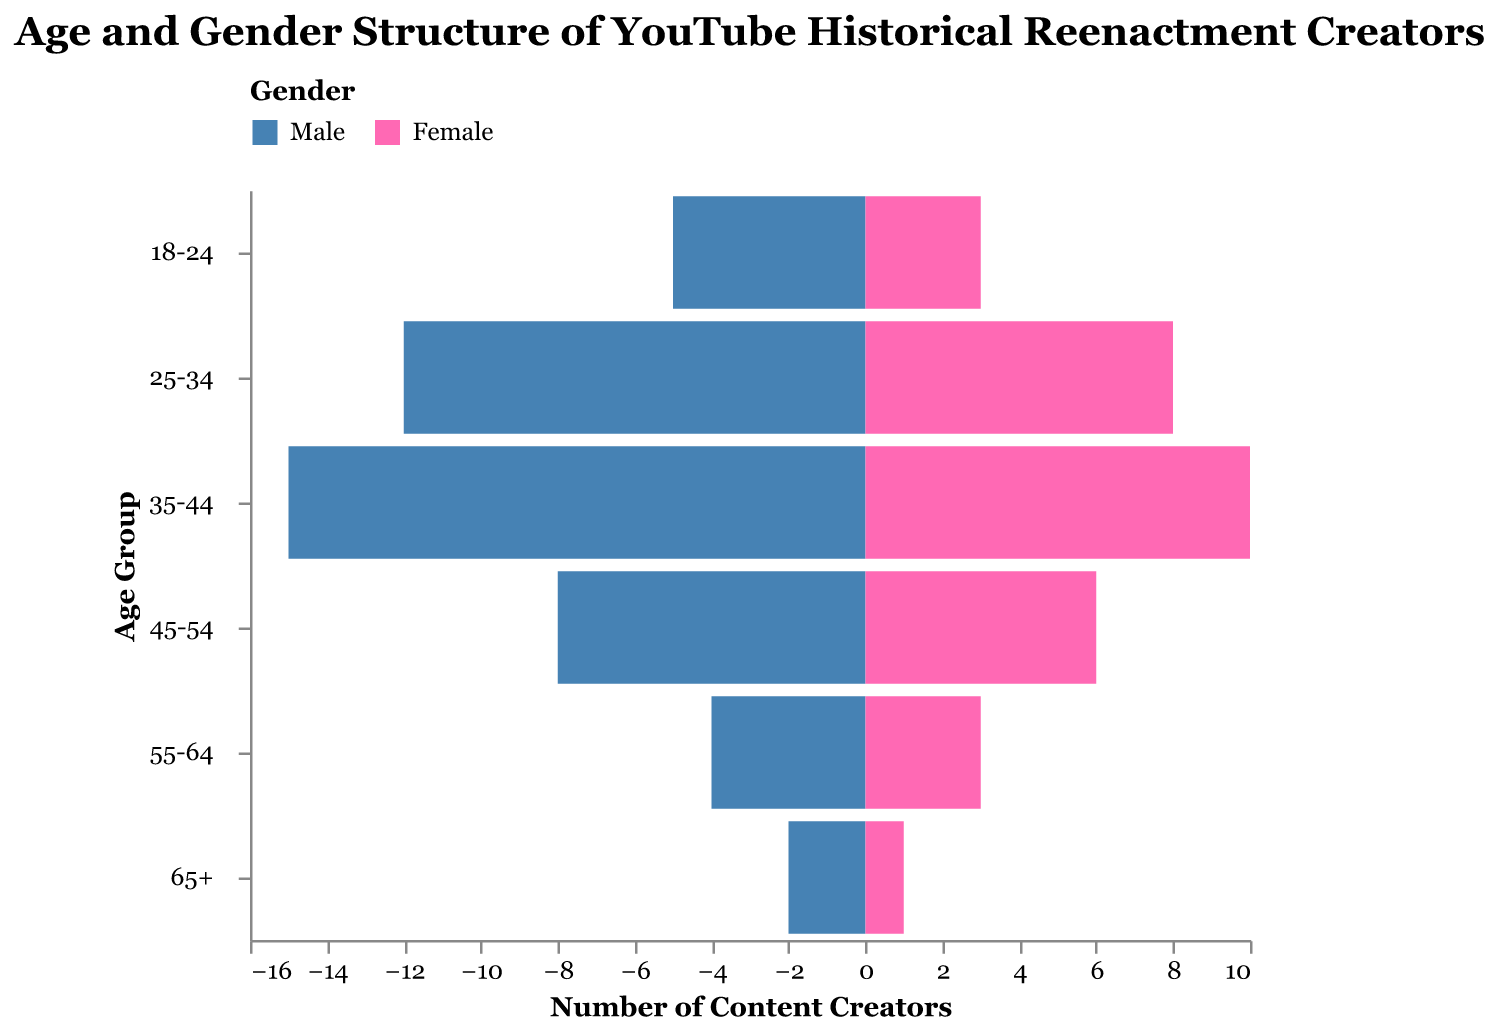What is the title of the figure? The title of the figure is displayed prominently at the top of the chart, allowing viewers to understand the context immediately.
Answer: Age and Gender Structure of YouTube Historical Reenactment Creators Which age group has the highest number of male content creators? The bar with the largest negative value on the x-axis within the respective age group indicates the highest number of male content creators. In this case, it is the 35-44 age group.
Answer: 35-44 How many female content creators are there in the 45-54 age group? By locating the bar for females in the 45-54 age group on the x-axis, we can see the value represented.
Answer: 6 What’s the total number of content creators in the 25-34 age group? Add the number of male and female content creators in the 25-34 age group (12 males + 8 females).
Answer: 20 Which gender has more content creators in the 55-64 age group? Compare the length of the bars for males and females in the 55-64 age group on the x-axis.
Answer: Male How do the number of males and females compare in the 18-24 age group? Compare the values of the bars for both males and females in the 18-24 age group. There are 5 males and 3 females.
Answer: 2 more males than females What is the age group with the least total number of content creators? Sum the number of males and females in each age group and identify the one with the lowest total. The 65+ age group has a total of 3 creators (2 males + 1 female).
Answer: 65+ Which age group has the closest number of male and female content creators? Calculate the absolute difference between the number of male and female content creators in each age group. The 45-54 age group has the closest numbers with a difference of 2 (8 males and 6 females).
Answer: 45-54 What is the average number of female content creators across all age groups? Sum the number of female content creators in all age groups (3+8+10+6+3+1 = 31) and divide by the total number of age groups (6).
Answer: 5.17 Is there any age group where the number of female content creators exceeds the number of male content creators? Compare the values of male and female content creators across all age groups. No age group has more female content creators than male content creators.
Answer: No 